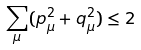<formula> <loc_0><loc_0><loc_500><loc_500>\sum _ { \mu } ( p _ { \mu } ^ { 2 } + q _ { \mu } ^ { 2 } ) \leq 2</formula> 